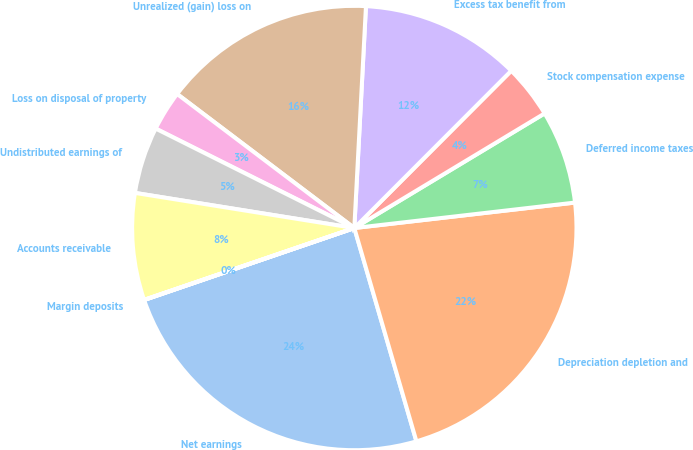Convert chart to OTSL. <chart><loc_0><loc_0><loc_500><loc_500><pie_chart><fcel>Net earnings<fcel>Depreciation depletion and<fcel>Deferred income taxes<fcel>Stock compensation expense<fcel>Excess tax benefit from<fcel>Unrealized (gain) loss on<fcel>Loss on disposal of property<fcel>Undistributed earnings of<fcel>Accounts receivable<fcel>Margin deposits<nl><fcel>24.26%<fcel>22.32%<fcel>6.8%<fcel>3.89%<fcel>11.65%<fcel>15.53%<fcel>2.92%<fcel>4.86%<fcel>7.77%<fcel>0.01%<nl></chart> 